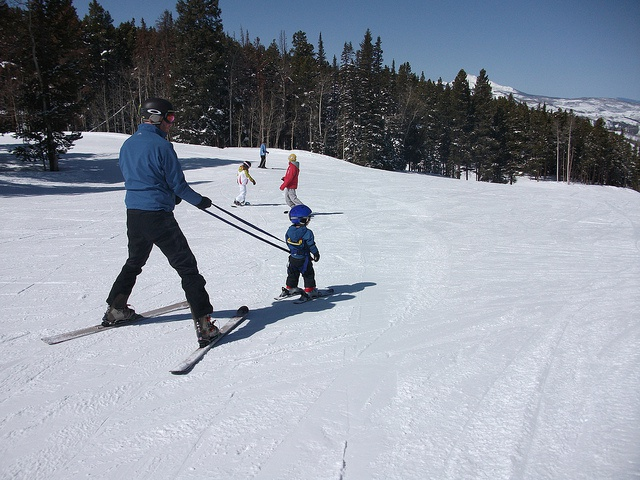Describe the objects in this image and their specific colors. I can see people in darkblue, black, navy, and blue tones, skis in darkblue, darkgray, black, lightgray, and gray tones, people in darkblue, black, navy, blue, and lightgray tones, people in darkblue, darkgray, maroon, brown, and gray tones, and people in darkblue, lavender, darkgray, and black tones in this image. 